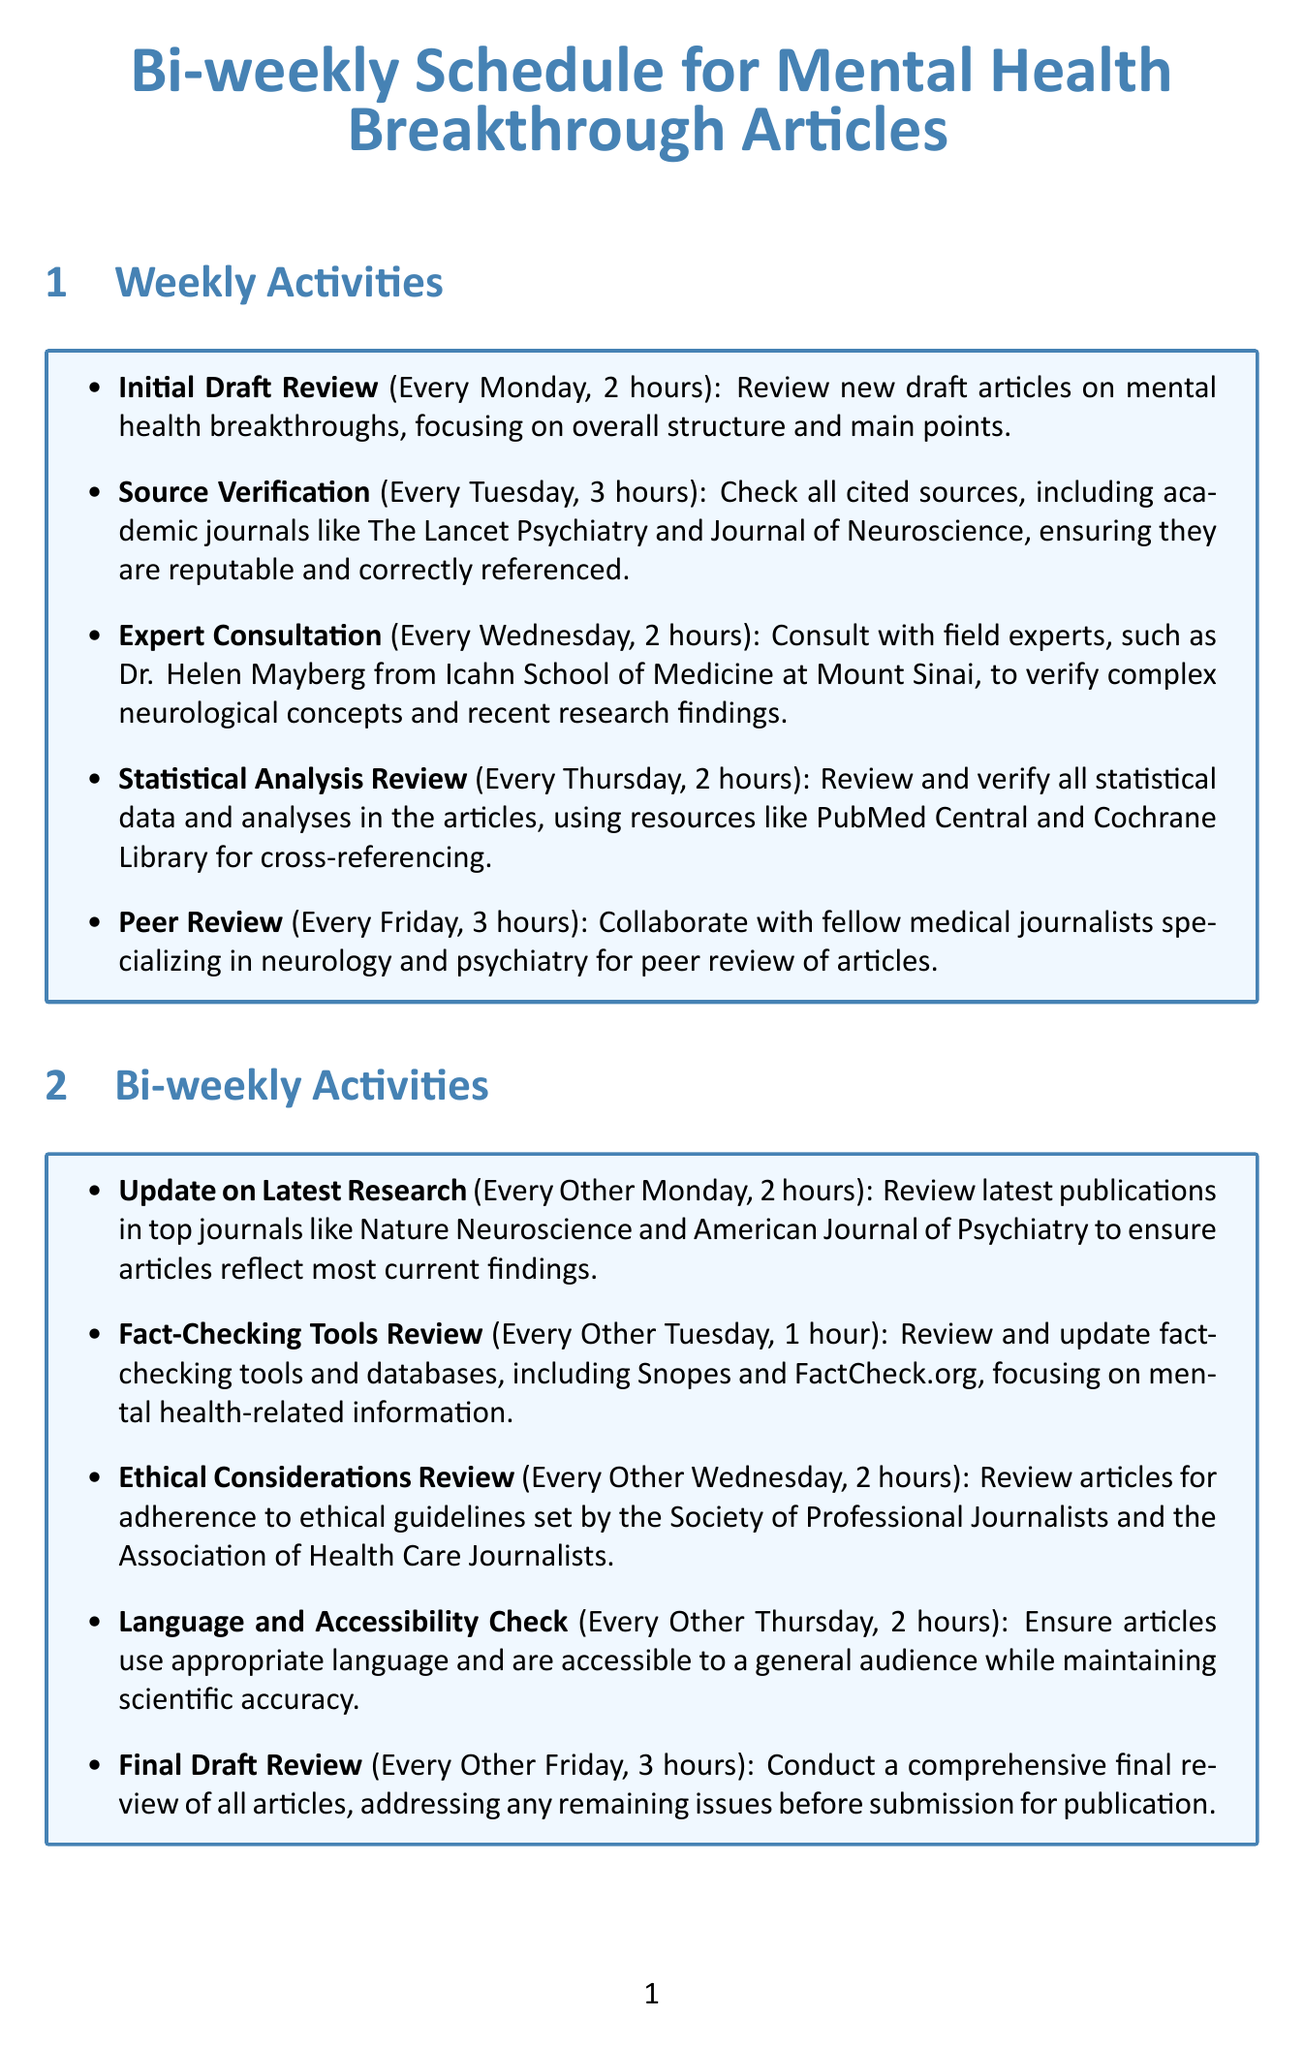What activity occurs every Monday? The activity scheduled for every Monday is the Initial Draft Review.
Answer: Initial Draft Review How long is the Source Verification activity? The duration of the Source Verification activity is stated in the document as three hours.
Answer: 3 hours Which expert specializes in bipolar disorder? The document lists Dr. Carrie Bearden as an expert in bipolar disorder.
Answer: Dr. Carrie Bearden What is the focus of the Ethical Considerations Review? The Ethical Considerations Review focuses on adherence to ethical guidelines set by professional organizations.
Answer: Adherence to ethical guidelines When is the Final Draft Review conducted? The Final Draft Review is scheduled for every other Friday.
Answer: Every Other Friday 